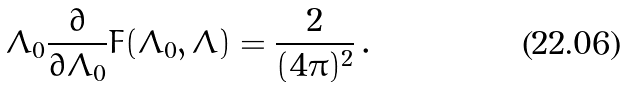Convert formula to latex. <formula><loc_0><loc_0><loc_500><loc_500>\Lambda _ { 0 } \frac { \partial } { \partial \Lambda _ { 0 } } F ( \Lambda _ { 0 } , \Lambda ) = \frac { 2 } { ( 4 \pi ) ^ { 2 } } \, .</formula> 